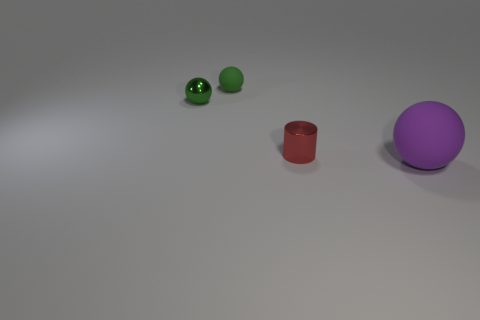Are there more tiny things that are left of the tiny cylinder than big green metallic things?
Your answer should be very brief. Yes. The rubber object behind the big rubber thing is what color?
Make the answer very short. Green. How many matte things are small green objects or red things?
Offer a very short reply. 1. Is there a tiny cylinder in front of the rubber object that is behind the matte sphere that is on the right side of the cylinder?
Ensure brevity in your answer.  Yes. There is a green metal object; what number of small red metal objects are behind it?
Make the answer very short. 0. There is another small ball that is the same color as the metal ball; what is its material?
Provide a short and direct response. Rubber. How many big things are purple balls or metallic balls?
Your answer should be very brief. 1. What is the shape of the metallic thing on the right side of the tiny rubber object?
Your answer should be compact. Cylinder. Are there any other shiny spheres that have the same color as the metal ball?
Make the answer very short. No. There is a rubber object that is behind the small shiny cylinder; is it the same size as the rubber object that is in front of the shiny ball?
Your answer should be very brief. No. 